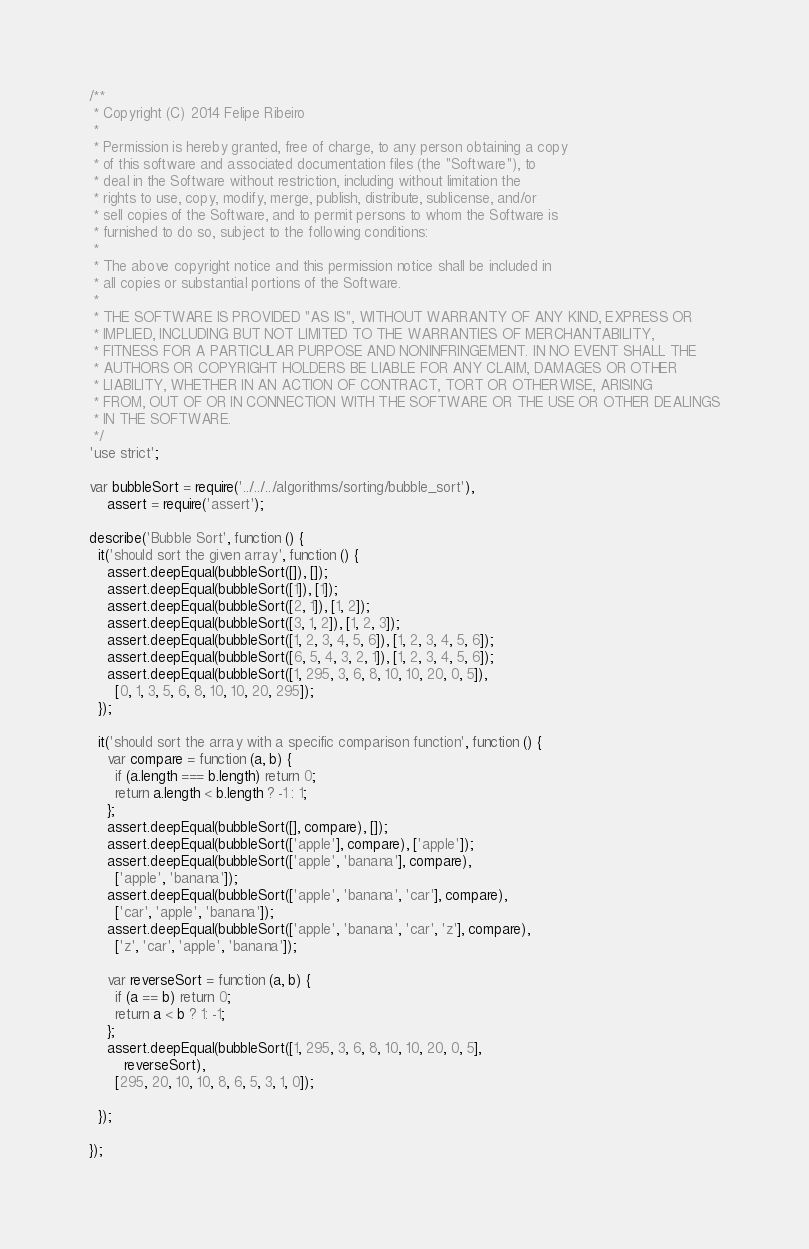<code> <loc_0><loc_0><loc_500><loc_500><_JavaScript_>/**
 * Copyright (C) 2014 Felipe Ribeiro
 *
 * Permission is hereby granted, free of charge, to any person obtaining a copy
 * of this software and associated documentation files (the "Software"), to
 * deal in the Software without restriction, including without limitation the
 * rights to use, copy, modify, merge, publish, distribute, sublicense, and/or
 * sell copies of the Software, and to permit persons to whom the Software is
 * furnished to do so, subject to the following conditions:
 *
 * The above copyright notice and this permission notice shall be included in
 * all copies or substantial portions of the Software.
 *
 * THE SOFTWARE IS PROVIDED "AS IS", WITHOUT WARRANTY OF ANY KIND, EXPRESS OR
 * IMPLIED, INCLUDING BUT NOT LIMITED TO THE WARRANTIES OF MERCHANTABILITY,
 * FITNESS FOR A PARTICULAR PURPOSE AND NONINFRINGEMENT. IN NO EVENT SHALL THE
 * AUTHORS OR COPYRIGHT HOLDERS BE LIABLE FOR ANY CLAIM, DAMAGES OR OTHER
 * LIABILITY, WHETHER IN AN ACTION OF CONTRACT, TORT OR OTHERWISE, ARISING
 * FROM, OUT OF OR IN CONNECTION WITH THE SOFTWARE OR THE USE OR OTHER DEALINGS
 * IN THE SOFTWARE.
 */
'use strict';

var bubbleSort = require('../../../algorithms/sorting/bubble_sort'),
    assert = require('assert');

describe('Bubble Sort', function () {
  it('should sort the given array', function () {
    assert.deepEqual(bubbleSort([]), []);
    assert.deepEqual(bubbleSort([1]), [1]);
    assert.deepEqual(bubbleSort([2, 1]), [1, 2]);
    assert.deepEqual(bubbleSort([3, 1, 2]), [1, 2, 3]);
    assert.deepEqual(bubbleSort([1, 2, 3, 4, 5, 6]), [1, 2, 3, 4, 5, 6]);
    assert.deepEqual(bubbleSort([6, 5, 4, 3, 2, 1]), [1, 2, 3, 4, 5, 6]);
    assert.deepEqual(bubbleSort([1, 295, 3, 6, 8, 10, 10, 20, 0, 5]),
      [0, 1, 3, 5, 6, 8, 10, 10, 20, 295]);
  });

  it('should sort the array with a specific comparison function', function () {
    var compare = function (a, b) {
      if (a.length === b.length) return 0;
      return a.length < b.length ? -1 : 1;
    };
    assert.deepEqual(bubbleSort([], compare), []);
    assert.deepEqual(bubbleSort(['apple'], compare), ['apple']);
    assert.deepEqual(bubbleSort(['apple', 'banana'], compare),
      ['apple', 'banana']);
    assert.deepEqual(bubbleSort(['apple', 'banana', 'car'], compare),
      ['car', 'apple', 'banana']);
    assert.deepEqual(bubbleSort(['apple', 'banana', 'car', 'z'], compare),
      ['z', 'car', 'apple', 'banana']);

    var reverseSort = function (a, b) {
      if (a == b) return 0;
      return a < b ? 1: -1;
    };
    assert.deepEqual(bubbleSort([1, 295, 3, 6, 8, 10, 10, 20, 0, 5],
        reverseSort),
      [295, 20, 10, 10, 8, 6, 5, 3, 1, 0]);

  });

});
</code> 